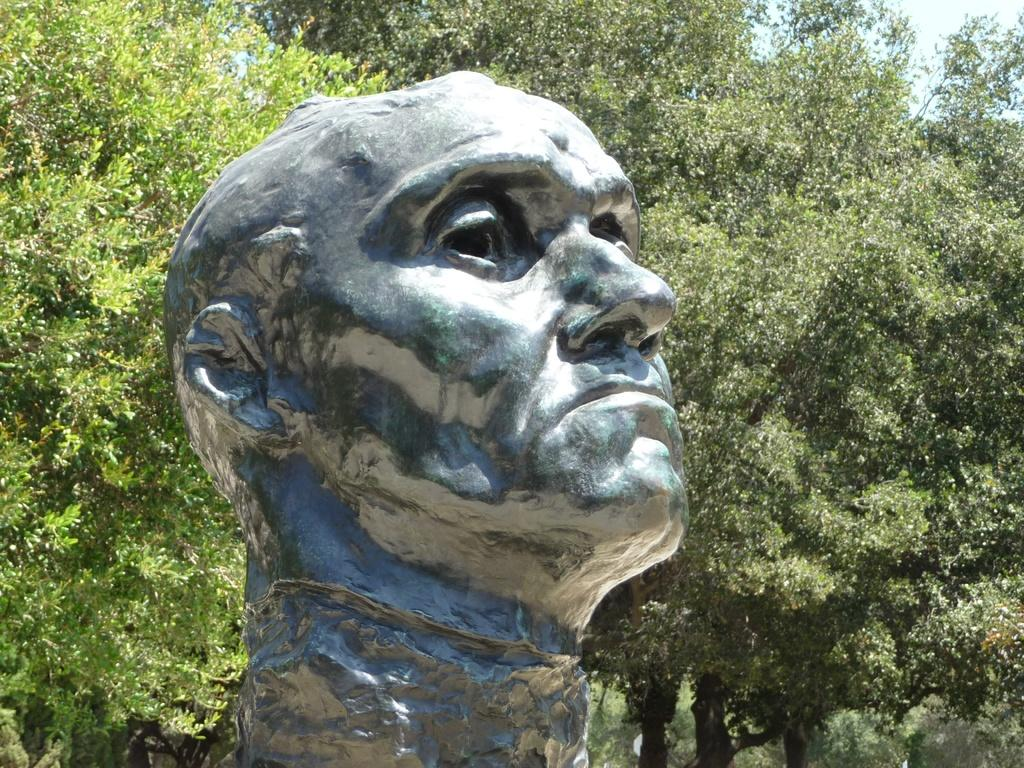What is the main subject in the middle of the image? There is a statue in the middle of the image. What can be seen behind the statue? There are trees behind the statue. What part of the sky is visible in the image? The sky is visible in the top right corner of the image. How many boats are docked in the harbor in the image? There is no harbor or boats present in the image; it features a statue with trees behind it and a portion of the sky visible. 